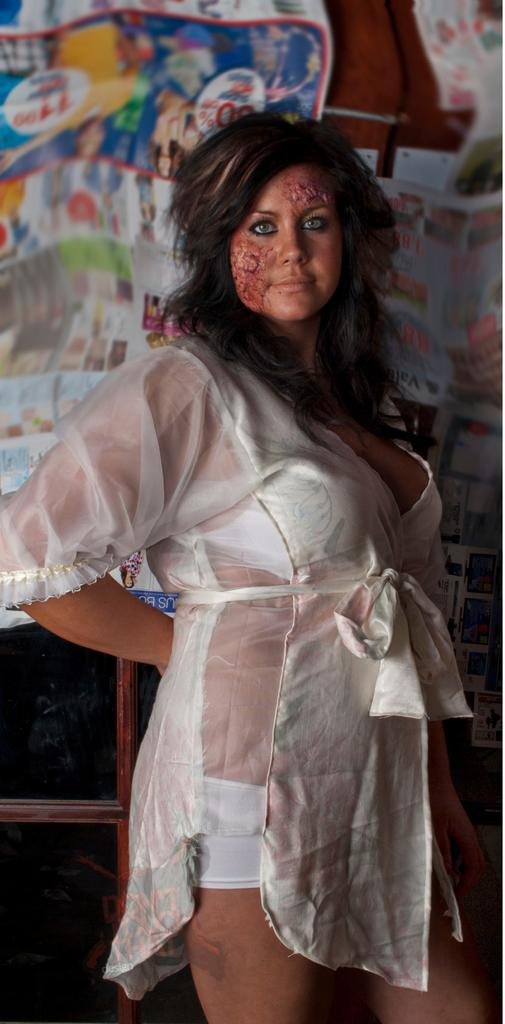Who is the main subject in the image? There is a woman in the image. What is the woman doing in the image? The woman is standing on the floor. What can be seen in the background of the image? There is a curtain in the background of the image. What arithmetic problem is the woman solving in the image? There is no arithmetic problem visible in the image, as it only features a woman standing on the floor with a curtain in the background. 